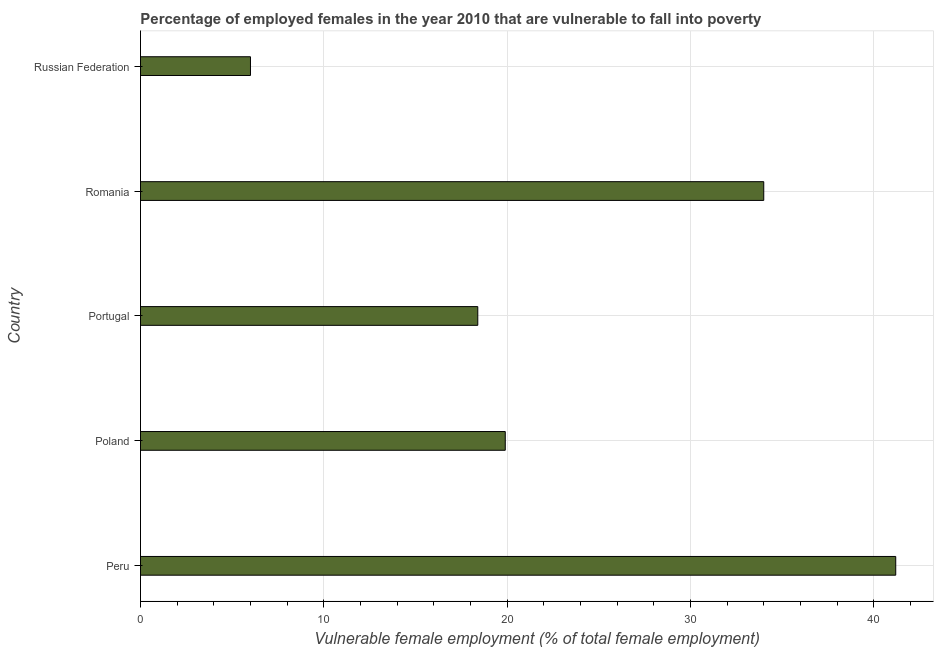What is the title of the graph?
Your answer should be compact. Percentage of employed females in the year 2010 that are vulnerable to fall into poverty. What is the label or title of the X-axis?
Provide a succinct answer. Vulnerable female employment (% of total female employment). What is the label or title of the Y-axis?
Provide a succinct answer. Country. What is the percentage of employed females who are vulnerable to fall into poverty in Peru?
Ensure brevity in your answer.  41.2. Across all countries, what is the maximum percentage of employed females who are vulnerable to fall into poverty?
Ensure brevity in your answer.  41.2. Across all countries, what is the minimum percentage of employed females who are vulnerable to fall into poverty?
Offer a very short reply. 6. In which country was the percentage of employed females who are vulnerable to fall into poverty minimum?
Provide a succinct answer. Russian Federation. What is the sum of the percentage of employed females who are vulnerable to fall into poverty?
Your answer should be very brief. 119.5. What is the difference between the percentage of employed females who are vulnerable to fall into poverty in Peru and Romania?
Offer a terse response. 7.2. What is the average percentage of employed females who are vulnerable to fall into poverty per country?
Make the answer very short. 23.9. What is the median percentage of employed females who are vulnerable to fall into poverty?
Make the answer very short. 19.9. What is the ratio of the percentage of employed females who are vulnerable to fall into poverty in Peru to that in Russian Federation?
Offer a terse response. 6.87. Is the difference between the percentage of employed females who are vulnerable to fall into poverty in Peru and Russian Federation greater than the difference between any two countries?
Offer a terse response. Yes. Is the sum of the percentage of employed females who are vulnerable to fall into poverty in Peru and Poland greater than the maximum percentage of employed females who are vulnerable to fall into poverty across all countries?
Make the answer very short. Yes. What is the difference between the highest and the lowest percentage of employed females who are vulnerable to fall into poverty?
Keep it short and to the point. 35.2. What is the difference between two consecutive major ticks on the X-axis?
Make the answer very short. 10. Are the values on the major ticks of X-axis written in scientific E-notation?
Make the answer very short. No. What is the Vulnerable female employment (% of total female employment) in Peru?
Your answer should be compact. 41.2. What is the Vulnerable female employment (% of total female employment) of Poland?
Offer a very short reply. 19.9. What is the Vulnerable female employment (% of total female employment) of Portugal?
Ensure brevity in your answer.  18.4. What is the Vulnerable female employment (% of total female employment) in Russian Federation?
Your answer should be very brief. 6. What is the difference between the Vulnerable female employment (% of total female employment) in Peru and Poland?
Keep it short and to the point. 21.3. What is the difference between the Vulnerable female employment (% of total female employment) in Peru and Portugal?
Make the answer very short. 22.8. What is the difference between the Vulnerable female employment (% of total female employment) in Peru and Romania?
Keep it short and to the point. 7.2. What is the difference between the Vulnerable female employment (% of total female employment) in Peru and Russian Federation?
Provide a short and direct response. 35.2. What is the difference between the Vulnerable female employment (% of total female employment) in Poland and Romania?
Provide a short and direct response. -14.1. What is the difference between the Vulnerable female employment (% of total female employment) in Poland and Russian Federation?
Your response must be concise. 13.9. What is the difference between the Vulnerable female employment (% of total female employment) in Portugal and Romania?
Give a very brief answer. -15.6. What is the difference between the Vulnerable female employment (% of total female employment) in Portugal and Russian Federation?
Offer a terse response. 12.4. What is the ratio of the Vulnerable female employment (% of total female employment) in Peru to that in Poland?
Make the answer very short. 2.07. What is the ratio of the Vulnerable female employment (% of total female employment) in Peru to that in Portugal?
Your answer should be compact. 2.24. What is the ratio of the Vulnerable female employment (% of total female employment) in Peru to that in Romania?
Provide a succinct answer. 1.21. What is the ratio of the Vulnerable female employment (% of total female employment) in Peru to that in Russian Federation?
Provide a short and direct response. 6.87. What is the ratio of the Vulnerable female employment (% of total female employment) in Poland to that in Portugal?
Keep it short and to the point. 1.08. What is the ratio of the Vulnerable female employment (% of total female employment) in Poland to that in Romania?
Keep it short and to the point. 0.58. What is the ratio of the Vulnerable female employment (% of total female employment) in Poland to that in Russian Federation?
Offer a terse response. 3.32. What is the ratio of the Vulnerable female employment (% of total female employment) in Portugal to that in Romania?
Keep it short and to the point. 0.54. What is the ratio of the Vulnerable female employment (% of total female employment) in Portugal to that in Russian Federation?
Your response must be concise. 3.07. What is the ratio of the Vulnerable female employment (% of total female employment) in Romania to that in Russian Federation?
Offer a terse response. 5.67. 